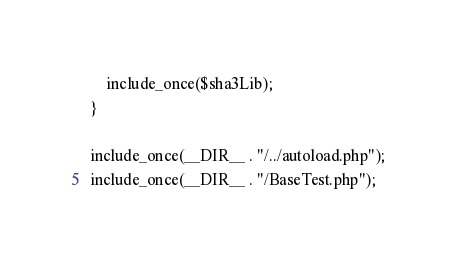Convert code to text. <code><loc_0><loc_0><loc_500><loc_500><_PHP_>    include_once($sha3Lib);
}

include_once(__DIR__ . "/../autoload.php");
include_once(__DIR__ . "/BaseTest.php");
</code> 